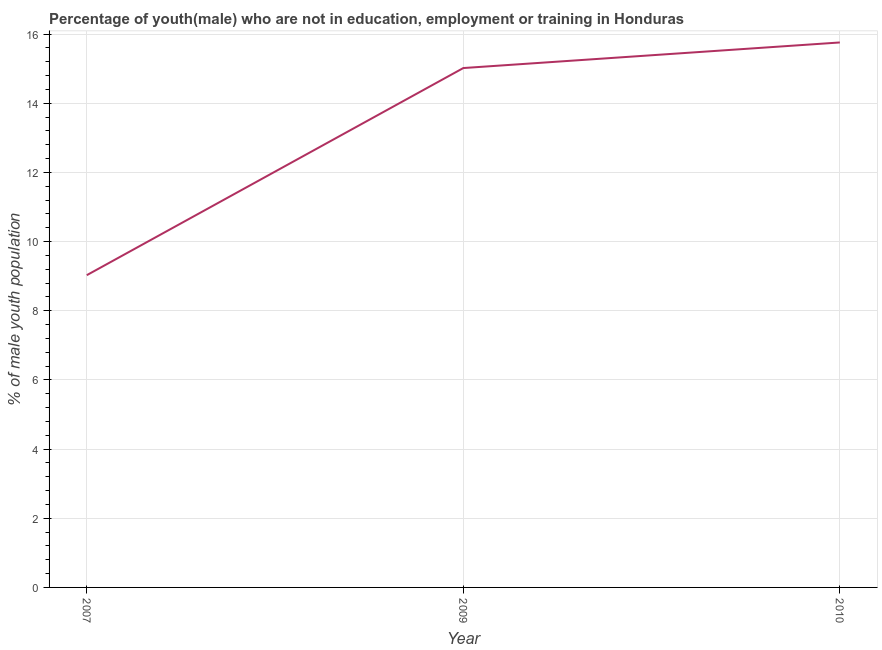What is the unemployed male youth population in 2009?
Provide a succinct answer. 15.02. Across all years, what is the maximum unemployed male youth population?
Provide a succinct answer. 15.76. Across all years, what is the minimum unemployed male youth population?
Your response must be concise. 9.03. In which year was the unemployed male youth population maximum?
Your answer should be very brief. 2010. What is the sum of the unemployed male youth population?
Offer a terse response. 39.81. What is the difference between the unemployed male youth population in 2009 and 2010?
Your answer should be very brief. -0.74. What is the average unemployed male youth population per year?
Offer a terse response. 13.27. What is the median unemployed male youth population?
Keep it short and to the point. 15.02. What is the ratio of the unemployed male youth population in 2007 to that in 2009?
Give a very brief answer. 0.6. Is the unemployed male youth population in 2007 less than that in 2010?
Make the answer very short. Yes. Is the difference between the unemployed male youth population in 2007 and 2009 greater than the difference between any two years?
Provide a succinct answer. No. What is the difference between the highest and the second highest unemployed male youth population?
Ensure brevity in your answer.  0.74. What is the difference between the highest and the lowest unemployed male youth population?
Your response must be concise. 6.73. In how many years, is the unemployed male youth population greater than the average unemployed male youth population taken over all years?
Your answer should be very brief. 2. Does the unemployed male youth population monotonically increase over the years?
Ensure brevity in your answer.  Yes. How many lines are there?
Provide a succinct answer. 1. Does the graph contain any zero values?
Make the answer very short. No. What is the title of the graph?
Ensure brevity in your answer.  Percentage of youth(male) who are not in education, employment or training in Honduras. What is the label or title of the Y-axis?
Provide a short and direct response. % of male youth population. What is the % of male youth population in 2007?
Make the answer very short. 9.03. What is the % of male youth population in 2009?
Offer a very short reply. 15.02. What is the % of male youth population of 2010?
Keep it short and to the point. 15.76. What is the difference between the % of male youth population in 2007 and 2009?
Keep it short and to the point. -5.99. What is the difference between the % of male youth population in 2007 and 2010?
Your response must be concise. -6.73. What is the difference between the % of male youth population in 2009 and 2010?
Make the answer very short. -0.74. What is the ratio of the % of male youth population in 2007 to that in 2009?
Your answer should be very brief. 0.6. What is the ratio of the % of male youth population in 2007 to that in 2010?
Make the answer very short. 0.57. What is the ratio of the % of male youth population in 2009 to that in 2010?
Make the answer very short. 0.95. 